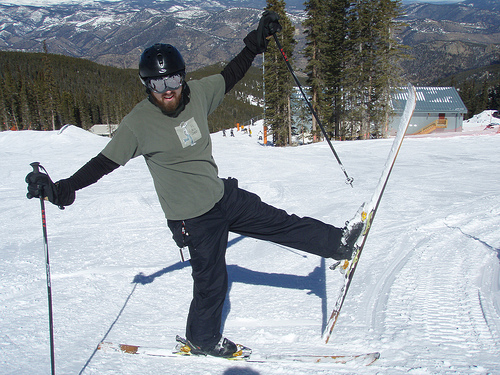<image>
Can you confirm if the man is above the snow? No. The man is not positioned above the snow. The vertical arrangement shows a different relationship. 